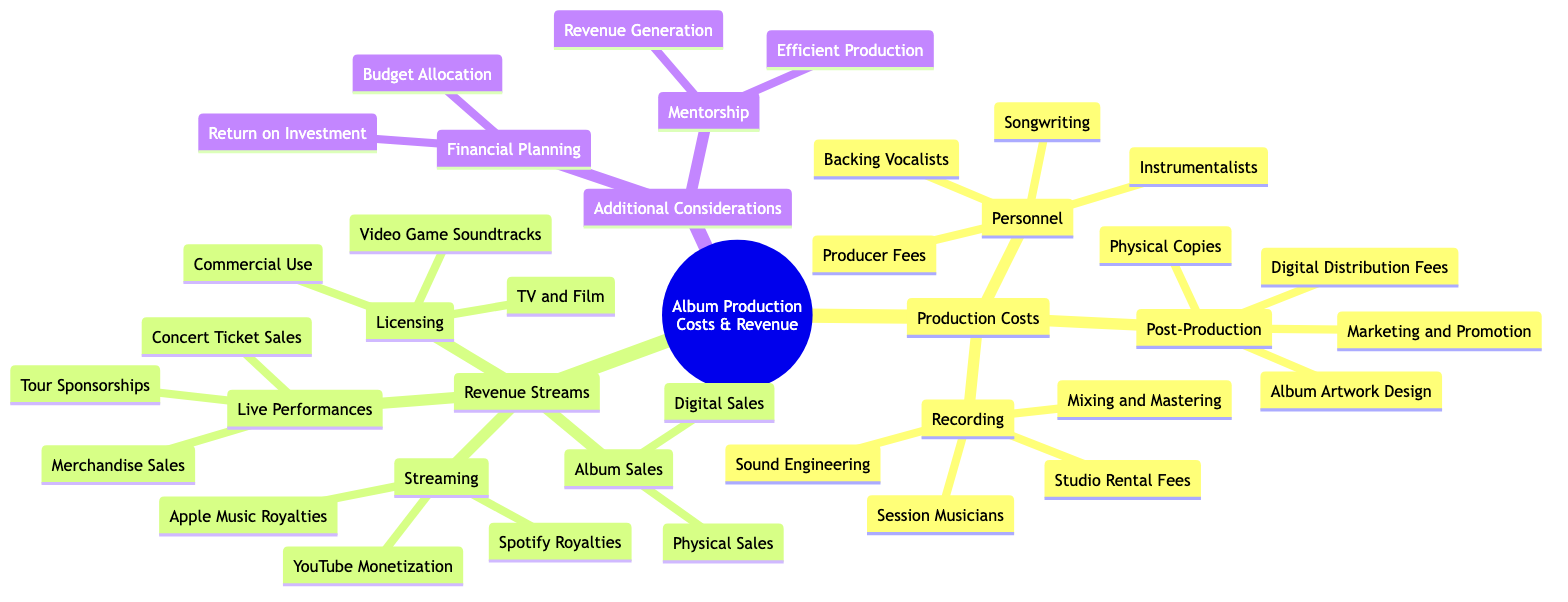What are the three main categories of Production Costs? The central topic "Production Costs" has three subcategories listed directly under it: "Recording," "Post-Production," and "Personnel." Each of these represents a key area of costs incurred in album production.
Answer: Recording, Post-Production, Personnel How many subtopics are under Revenue Streams? The main category "Revenue Streams" includes four distinct subcategories: "Album Sales," "Streaming," "Live Performances," and "Licensing." Counting these reveals the total number of subtopics.
Answer: 4 Which revenue stream includes Concert Ticket Sales? "Concert Ticket Sales" is listed under the subtopic "Live Performances," which is part of the broader area of revenue generation shown in the diagram.
Answer: Live Performances What are the two types of Album Sales mentioned? The diagram indicates that "Album Sales" consists of two types: "Physical Sales" and "Digital Sales." Both types are specifically outlined in the Revenue Streams section.
Answer: Physical Sales, Digital Sales How does the diagram categorize the role of a Producer? In the diagram, the role of a Producer falls under the "Personnel" category, where "Producer Fees" is specifically listed as a cost associated with album production. This indicates the financial aspect of hiring a producer.
Answer: Personnel Identify one financial consideration mentioned in the diagram. The "Financial Planning" subtopic under "Additional Considerations" includes "Budget Allocation," which is a primary concern for managing production costs and revenue effectively.
Answer: Budget Allocation Which subcategory includes Digital Distribution Fees? "Digital Distribution Fees" is a listed item under the "Post-Production" category in the diagram, denoting a specific cost incurred after the album recording process.
Answer: Post-Production What are two revenue-generating activities associated with Licensing? Under the "Licensing" category, two activities that generate revenue are explicitly mentioned: "Music for TV and Film" and "Commercial Use." These show how music can be monetized through various media.
Answer: Music for TV and Film, Commercial Use How is Mentorship related to the analysis in this diagram? The "Mentorship" subtopic under "Additional Considerations" indicates its significance in guiding artists toward "Efficient Production" and "Revenue Generation." This connection highlights the importance of experienced insights in navigating the production process.
Answer: Mentorship 